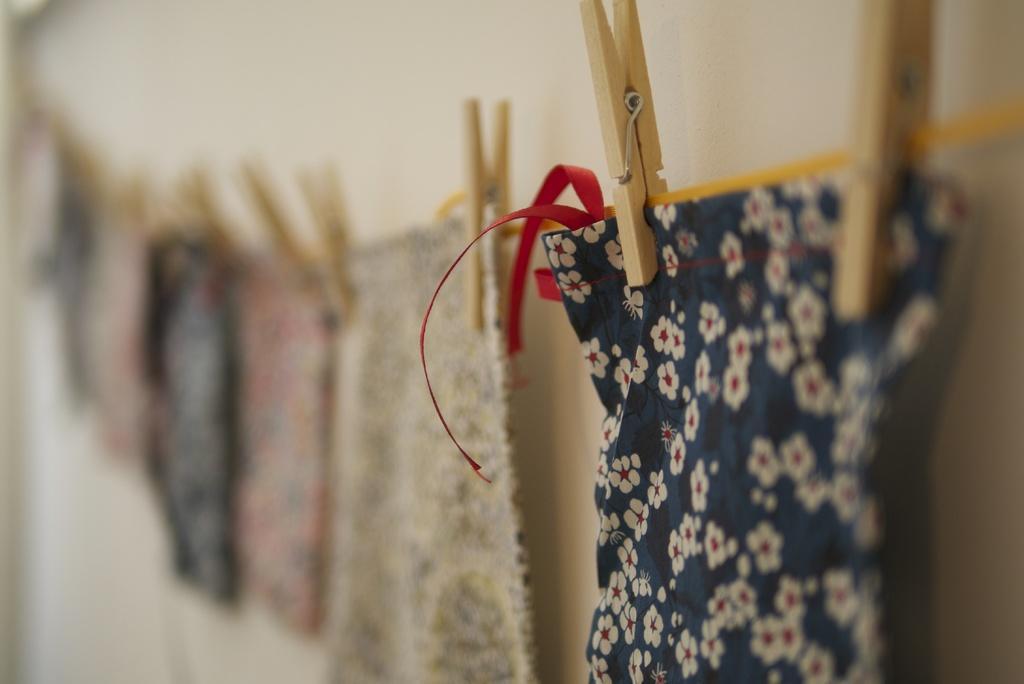How would you summarize this image in a sentence or two? In this image i can see few clothes hanged to a rope and wooden clips. 